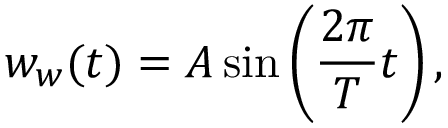<formula> <loc_0><loc_0><loc_500><loc_500>w _ { w } ( t ) = A \sin \left ( \frac { 2 \pi } { T } t \right ) ,</formula> 